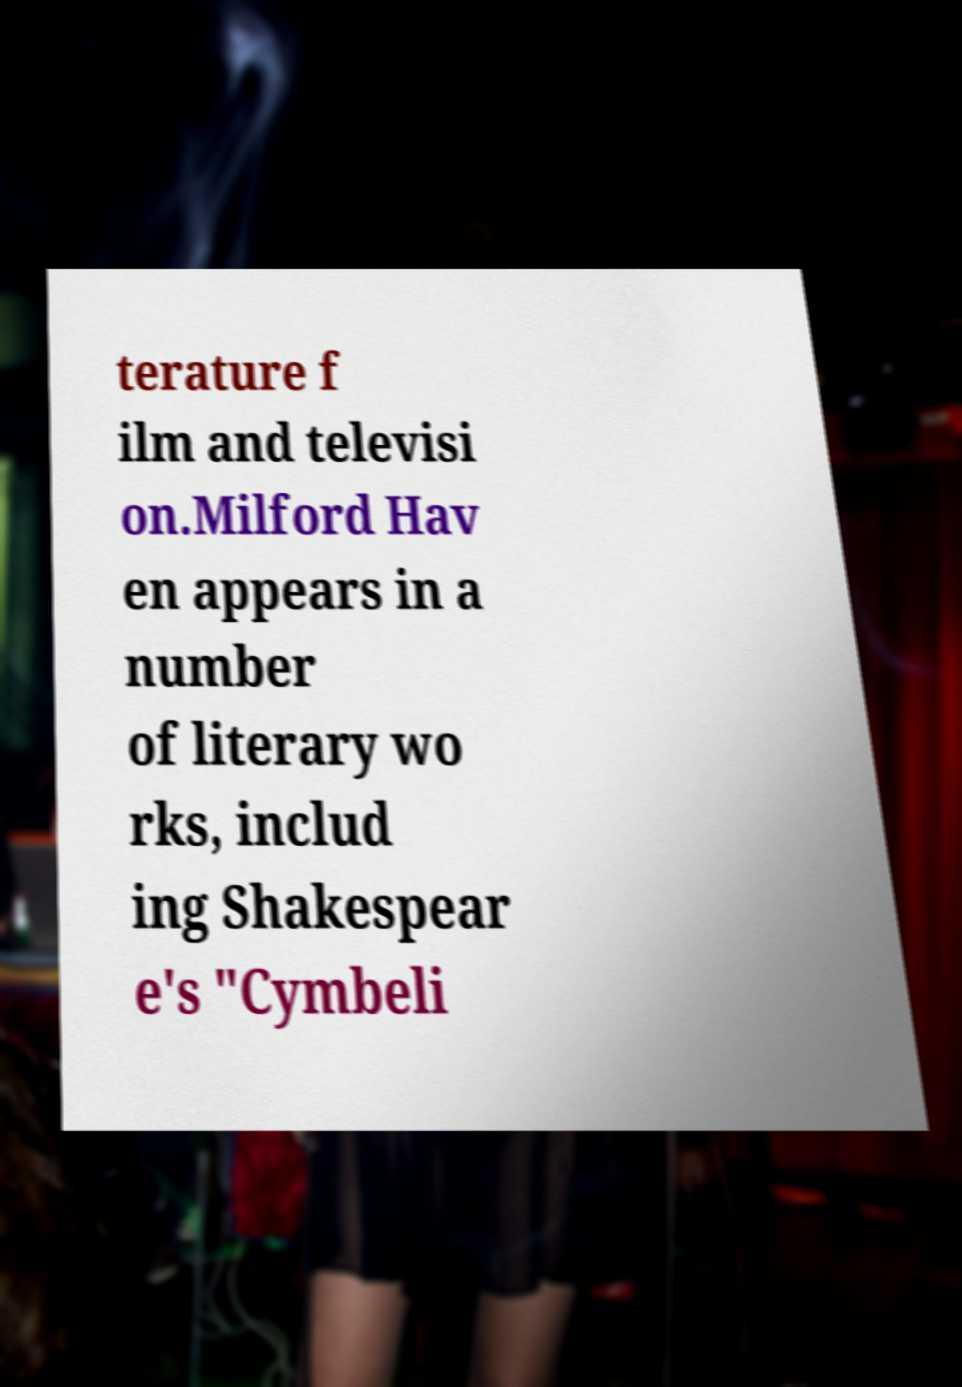Could you assist in decoding the text presented in this image and type it out clearly? terature f ilm and televisi on.Milford Hav en appears in a number of literary wo rks, includ ing Shakespear e's "Cymbeli 